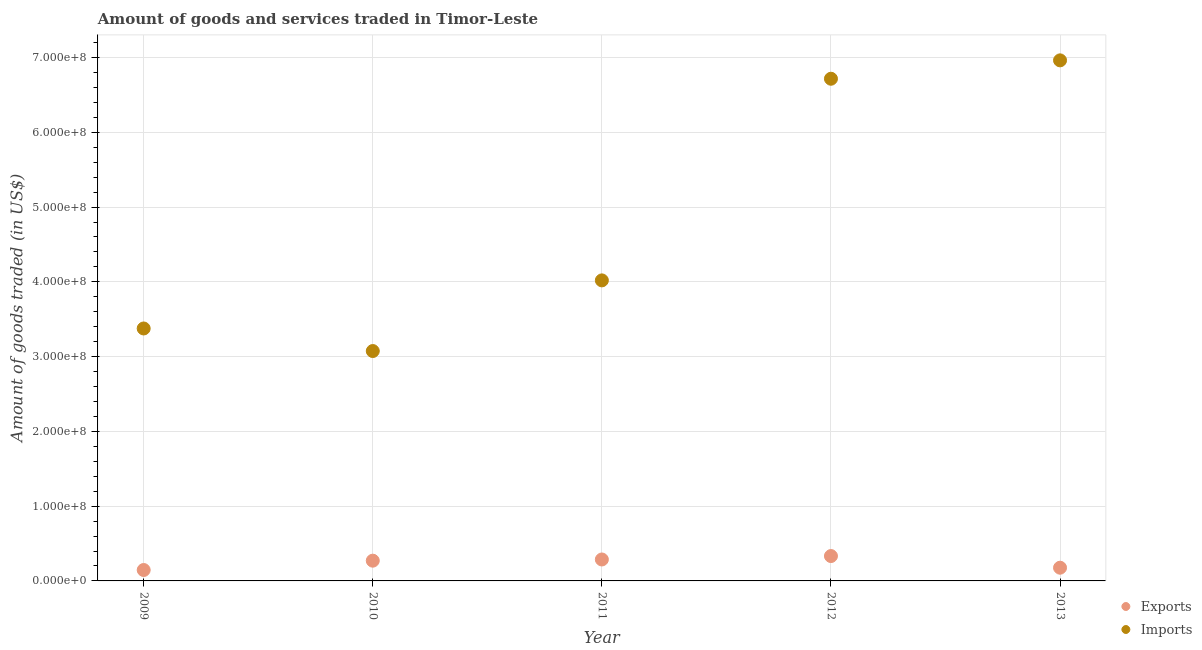What is the amount of goods imported in 2010?
Your answer should be compact. 3.07e+08. Across all years, what is the maximum amount of goods exported?
Your answer should be compact. 3.33e+07. Across all years, what is the minimum amount of goods imported?
Provide a succinct answer. 3.07e+08. In which year was the amount of goods imported maximum?
Offer a terse response. 2013. What is the total amount of goods exported in the graph?
Provide a succinct answer. 1.21e+08. What is the difference between the amount of goods exported in 2010 and that in 2011?
Your answer should be compact. -1.60e+06. What is the difference between the amount of goods imported in 2012 and the amount of goods exported in 2013?
Offer a very short reply. 6.54e+08. What is the average amount of goods exported per year?
Your answer should be compact. 2.43e+07. In the year 2009, what is the difference between the amount of goods imported and amount of goods exported?
Offer a terse response. 3.23e+08. In how many years, is the amount of goods imported greater than 180000000 US$?
Your answer should be very brief. 5. What is the ratio of the amount of goods imported in 2011 to that in 2013?
Provide a succinct answer. 0.58. Is the amount of goods exported in 2011 less than that in 2012?
Offer a very short reply. Yes. What is the difference between the highest and the second highest amount of goods exported?
Provide a succinct answer. 4.59e+06. What is the difference between the highest and the lowest amount of goods imported?
Provide a succinct answer. 3.89e+08. In how many years, is the amount of goods exported greater than the average amount of goods exported taken over all years?
Your answer should be compact. 3. Is the sum of the amount of goods imported in 2011 and 2013 greater than the maximum amount of goods exported across all years?
Offer a very short reply. Yes. How many dotlines are there?
Your response must be concise. 2. What is the difference between two consecutive major ticks on the Y-axis?
Give a very brief answer. 1.00e+08. Are the values on the major ticks of Y-axis written in scientific E-notation?
Offer a terse response. Yes. Does the graph contain any zero values?
Give a very brief answer. No. Does the graph contain grids?
Your answer should be compact. Yes. Where does the legend appear in the graph?
Offer a very short reply. Bottom right. How are the legend labels stacked?
Offer a terse response. Vertical. What is the title of the graph?
Give a very brief answer. Amount of goods and services traded in Timor-Leste. What is the label or title of the Y-axis?
Give a very brief answer. Amount of goods traded (in US$). What is the Amount of goods traded (in US$) in Exports in 2009?
Your answer should be compact. 1.46e+07. What is the Amount of goods traded (in US$) of Imports in 2009?
Your answer should be very brief. 3.38e+08. What is the Amount of goods traded (in US$) in Exports in 2010?
Offer a very short reply. 2.71e+07. What is the Amount of goods traded (in US$) in Imports in 2010?
Your response must be concise. 3.07e+08. What is the Amount of goods traded (in US$) of Exports in 2011?
Your answer should be compact. 2.87e+07. What is the Amount of goods traded (in US$) of Imports in 2011?
Offer a terse response. 4.02e+08. What is the Amount of goods traded (in US$) in Exports in 2012?
Keep it short and to the point. 3.33e+07. What is the Amount of goods traded (in US$) in Imports in 2012?
Make the answer very short. 6.72e+08. What is the Amount of goods traded (in US$) of Exports in 2013?
Ensure brevity in your answer.  1.77e+07. What is the Amount of goods traded (in US$) of Imports in 2013?
Offer a terse response. 6.96e+08. Across all years, what is the maximum Amount of goods traded (in US$) of Exports?
Give a very brief answer. 3.33e+07. Across all years, what is the maximum Amount of goods traded (in US$) of Imports?
Offer a very short reply. 6.96e+08. Across all years, what is the minimum Amount of goods traded (in US$) in Exports?
Provide a succinct answer. 1.46e+07. Across all years, what is the minimum Amount of goods traded (in US$) of Imports?
Offer a terse response. 3.07e+08. What is the total Amount of goods traded (in US$) in Exports in the graph?
Your answer should be compact. 1.21e+08. What is the total Amount of goods traded (in US$) of Imports in the graph?
Keep it short and to the point. 2.41e+09. What is the difference between the Amount of goods traded (in US$) of Exports in 2009 and that in 2010?
Provide a short and direct response. -1.25e+07. What is the difference between the Amount of goods traded (in US$) of Imports in 2009 and that in 2010?
Offer a very short reply. 3.02e+07. What is the difference between the Amount of goods traded (in US$) in Exports in 2009 and that in 2011?
Make the answer very short. -1.41e+07. What is the difference between the Amount of goods traded (in US$) of Imports in 2009 and that in 2011?
Provide a succinct answer. -6.43e+07. What is the difference between the Amount of goods traded (in US$) in Exports in 2009 and that in 2012?
Offer a terse response. -1.87e+07. What is the difference between the Amount of goods traded (in US$) in Imports in 2009 and that in 2012?
Offer a terse response. -3.34e+08. What is the difference between the Amount of goods traded (in US$) of Exports in 2009 and that in 2013?
Your answer should be compact. -3.08e+06. What is the difference between the Amount of goods traded (in US$) in Imports in 2009 and that in 2013?
Offer a very short reply. -3.59e+08. What is the difference between the Amount of goods traded (in US$) of Exports in 2010 and that in 2011?
Offer a very short reply. -1.60e+06. What is the difference between the Amount of goods traded (in US$) of Imports in 2010 and that in 2011?
Provide a succinct answer. -9.45e+07. What is the difference between the Amount of goods traded (in US$) in Exports in 2010 and that in 2012?
Make the answer very short. -6.19e+06. What is the difference between the Amount of goods traded (in US$) of Imports in 2010 and that in 2012?
Offer a terse response. -3.64e+08. What is the difference between the Amount of goods traded (in US$) of Exports in 2010 and that in 2013?
Keep it short and to the point. 9.41e+06. What is the difference between the Amount of goods traded (in US$) in Imports in 2010 and that in 2013?
Provide a succinct answer. -3.89e+08. What is the difference between the Amount of goods traded (in US$) of Exports in 2011 and that in 2012?
Ensure brevity in your answer.  -4.59e+06. What is the difference between the Amount of goods traded (in US$) in Imports in 2011 and that in 2012?
Provide a short and direct response. -2.70e+08. What is the difference between the Amount of goods traded (in US$) of Exports in 2011 and that in 2013?
Your answer should be compact. 1.10e+07. What is the difference between the Amount of goods traded (in US$) of Imports in 2011 and that in 2013?
Your answer should be compact. -2.94e+08. What is the difference between the Amount of goods traded (in US$) of Exports in 2012 and that in 2013?
Provide a short and direct response. 1.56e+07. What is the difference between the Amount of goods traded (in US$) of Imports in 2012 and that in 2013?
Make the answer very short. -2.46e+07. What is the difference between the Amount of goods traded (in US$) of Exports in 2009 and the Amount of goods traded (in US$) of Imports in 2010?
Offer a terse response. -2.93e+08. What is the difference between the Amount of goods traded (in US$) in Exports in 2009 and the Amount of goods traded (in US$) in Imports in 2011?
Provide a succinct answer. -3.87e+08. What is the difference between the Amount of goods traded (in US$) in Exports in 2009 and the Amount of goods traded (in US$) in Imports in 2012?
Ensure brevity in your answer.  -6.57e+08. What is the difference between the Amount of goods traded (in US$) in Exports in 2009 and the Amount of goods traded (in US$) in Imports in 2013?
Keep it short and to the point. -6.82e+08. What is the difference between the Amount of goods traded (in US$) in Exports in 2010 and the Amount of goods traded (in US$) in Imports in 2011?
Provide a succinct answer. -3.75e+08. What is the difference between the Amount of goods traded (in US$) in Exports in 2010 and the Amount of goods traded (in US$) in Imports in 2012?
Ensure brevity in your answer.  -6.45e+08. What is the difference between the Amount of goods traded (in US$) of Exports in 2010 and the Amount of goods traded (in US$) of Imports in 2013?
Give a very brief answer. -6.69e+08. What is the difference between the Amount of goods traded (in US$) of Exports in 2011 and the Amount of goods traded (in US$) of Imports in 2012?
Your answer should be very brief. -6.43e+08. What is the difference between the Amount of goods traded (in US$) in Exports in 2011 and the Amount of goods traded (in US$) in Imports in 2013?
Provide a succinct answer. -6.68e+08. What is the difference between the Amount of goods traded (in US$) of Exports in 2012 and the Amount of goods traded (in US$) of Imports in 2013?
Offer a terse response. -6.63e+08. What is the average Amount of goods traded (in US$) of Exports per year?
Your answer should be very brief. 2.43e+07. What is the average Amount of goods traded (in US$) in Imports per year?
Make the answer very short. 4.83e+08. In the year 2009, what is the difference between the Amount of goods traded (in US$) of Exports and Amount of goods traded (in US$) of Imports?
Offer a very short reply. -3.23e+08. In the year 2010, what is the difference between the Amount of goods traded (in US$) of Exports and Amount of goods traded (in US$) of Imports?
Your answer should be very brief. -2.80e+08. In the year 2011, what is the difference between the Amount of goods traded (in US$) in Exports and Amount of goods traded (in US$) in Imports?
Provide a short and direct response. -3.73e+08. In the year 2012, what is the difference between the Amount of goods traded (in US$) in Exports and Amount of goods traded (in US$) in Imports?
Your answer should be compact. -6.38e+08. In the year 2013, what is the difference between the Amount of goods traded (in US$) in Exports and Amount of goods traded (in US$) in Imports?
Give a very brief answer. -6.79e+08. What is the ratio of the Amount of goods traded (in US$) of Exports in 2009 to that in 2010?
Provide a succinct answer. 0.54. What is the ratio of the Amount of goods traded (in US$) of Imports in 2009 to that in 2010?
Offer a very short reply. 1.1. What is the ratio of the Amount of goods traded (in US$) in Exports in 2009 to that in 2011?
Your answer should be compact. 0.51. What is the ratio of the Amount of goods traded (in US$) in Imports in 2009 to that in 2011?
Offer a very short reply. 0.84. What is the ratio of the Amount of goods traded (in US$) of Exports in 2009 to that in 2012?
Your response must be concise. 0.44. What is the ratio of the Amount of goods traded (in US$) of Imports in 2009 to that in 2012?
Give a very brief answer. 0.5. What is the ratio of the Amount of goods traded (in US$) in Exports in 2009 to that in 2013?
Ensure brevity in your answer.  0.83. What is the ratio of the Amount of goods traded (in US$) in Imports in 2009 to that in 2013?
Provide a short and direct response. 0.48. What is the ratio of the Amount of goods traded (in US$) in Exports in 2010 to that in 2011?
Your answer should be compact. 0.94. What is the ratio of the Amount of goods traded (in US$) of Imports in 2010 to that in 2011?
Offer a terse response. 0.76. What is the ratio of the Amount of goods traded (in US$) in Exports in 2010 to that in 2012?
Your answer should be very brief. 0.81. What is the ratio of the Amount of goods traded (in US$) in Imports in 2010 to that in 2012?
Offer a very short reply. 0.46. What is the ratio of the Amount of goods traded (in US$) in Exports in 2010 to that in 2013?
Keep it short and to the point. 1.53. What is the ratio of the Amount of goods traded (in US$) in Imports in 2010 to that in 2013?
Make the answer very short. 0.44. What is the ratio of the Amount of goods traded (in US$) in Exports in 2011 to that in 2012?
Provide a short and direct response. 0.86. What is the ratio of the Amount of goods traded (in US$) of Imports in 2011 to that in 2012?
Your response must be concise. 0.6. What is the ratio of the Amount of goods traded (in US$) in Exports in 2011 to that in 2013?
Give a very brief answer. 1.62. What is the ratio of the Amount of goods traded (in US$) of Imports in 2011 to that in 2013?
Provide a succinct answer. 0.58. What is the ratio of the Amount of goods traded (in US$) in Exports in 2012 to that in 2013?
Your response must be concise. 1.88. What is the ratio of the Amount of goods traded (in US$) in Imports in 2012 to that in 2013?
Your answer should be very brief. 0.96. What is the difference between the highest and the second highest Amount of goods traded (in US$) in Exports?
Offer a very short reply. 4.59e+06. What is the difference between the highest and the second highest Amount of goods traded (in US$) in Imports?
Your answer should be compact. 2.46e+07. What is the difference between the highest and the lowest Amount of goods traded (in US$) in Exports?
Offer a very short reply. 1.87e+07. What is the difference between the highest and the lowest Amount of goods traded (in US$) in Imports?
Offer a terse response. 3.89e+08. 